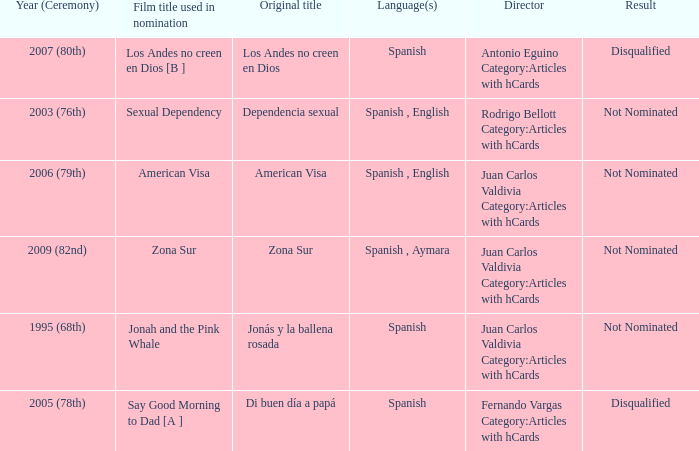What is Dependencia Sexual's film title that was used in its nomination? Sexual Dependency. 